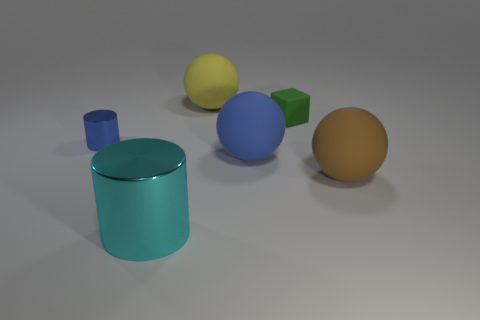Add 3 cyan metallic cylinders. How many objects exist? 9 Subtract all cylinders. How many objects are left? 4 Add 4 cyan things. How many cyan things are left? 5 Add 3 green objects. How many green objects exist? 4 Subtract 0 green cylinders. How many objects are left? 6 Subtract all small green things. Subtract all cyan cylinders. How many objects are left? 4 